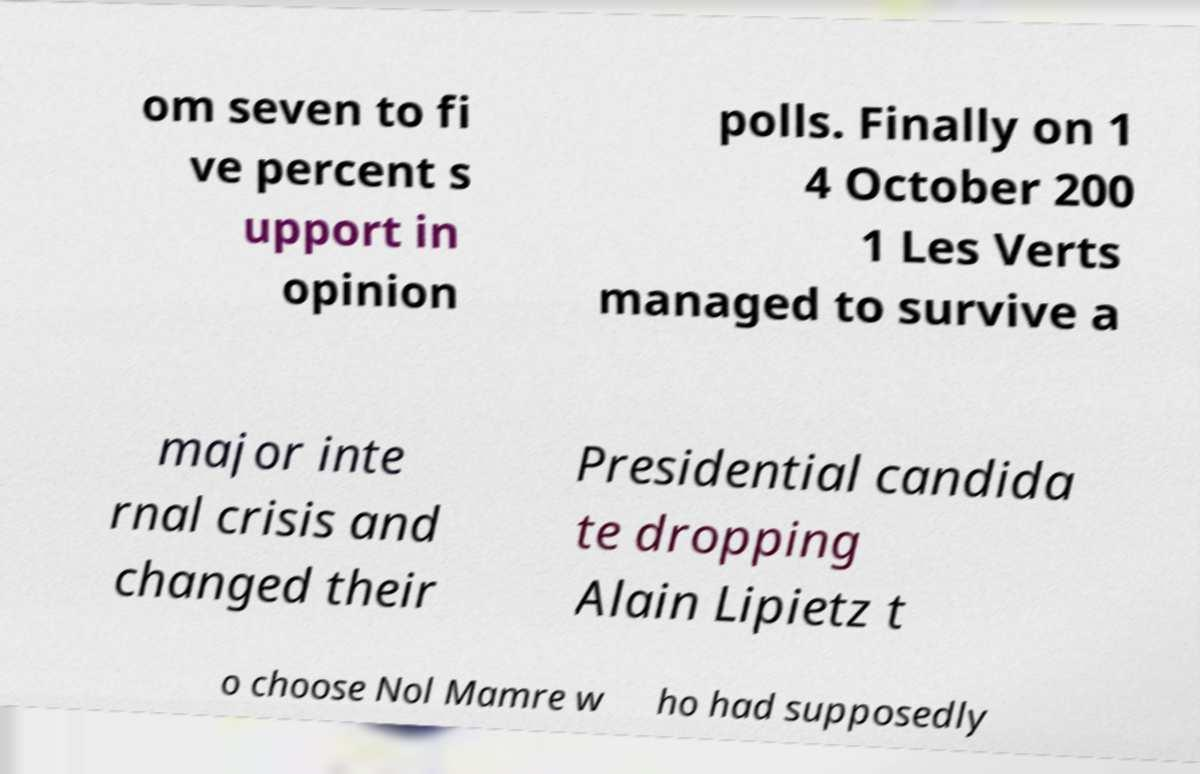Can you read and provide the text displayed in the image?This photo seems to have some interesting text. Can you extract and type it out for me? om seven to fi ve percent s upport in opinion polls. Finally on 1 4 October 200 1 Les Verts managed to survive a major inte rnal crisis and changed their Presidential candida te dropping Alain Lipietz t o choose Nol Mamre w ho had supposedly 